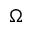<formula> <loc_0><loc_0><loc_500><loc_500>\Omega</formula> 